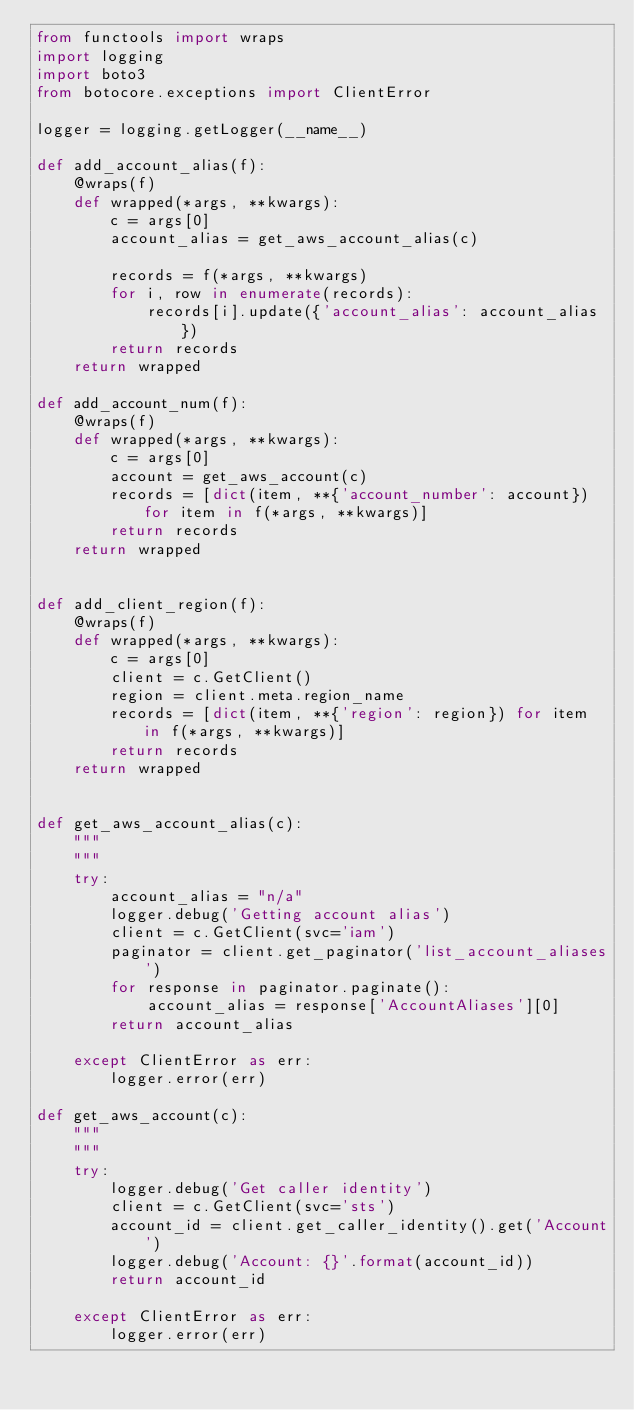<code> <loc_0><loc_0><loc_500><loc_500><_Python_>from functools import wraps
import logging
import boto3
from botocore.exceptions import ClientError

logger = logging.getLogger(__name__)

def add_account_alias(f):
    @wraps(f)
    def wrapped(*args, **kwargs):
        c = args[0]
        account_alias = get_aws_account_alias(c)

        records = f(*args, **kwargs)
        for i, row in enumerate(records):
            records[i].update({'account_alias': account_alias})
        return records
    return wrapped

def add_account_num(f):
    @wraps(f)
    def wrapped(*args, **kwargs):
        c = args[0]
        account = get_aws_account(c)
        records = [dict(item, **{'account_number': account}) for item in f(*args, **kwargs)]
        return records
    return wrapped


def add_client_region(f):
    @wraps(f)
    def wrapped(*args, **kwargs):
        c = args[0]
        client = c.GetClient()
        region = client.meta.region_name
        records = [dict(item, **{'region': region}) for item in f(*args, **kwargs)]
        return records
    return wrapped


def get_aws_account_alias(c):
    """
    """
    try:
        account_alias = "n/a"
        logger.debug('Getting account alias')
        client = c.GetClient(svc='iam')
        paginator = client.get_paginator('list_account_aliases')
        for response in paginator.paginate():
            account_alias = response['AccountAliases'][0]
        return account_alias

    except ClientError as err:
        logger.error(err)
        
def get_aws_account(c):
    """
    """
    try:
        logger.debug('Get caller identity')
        client = c.GetClient(svc='sts')
        account_id = client.get_caller_identity().get('Account')
        logger.debug('Account: {}'.format(account_id))
        return account_id

    except ClientError as err:
        logger.error(err)

</code> 